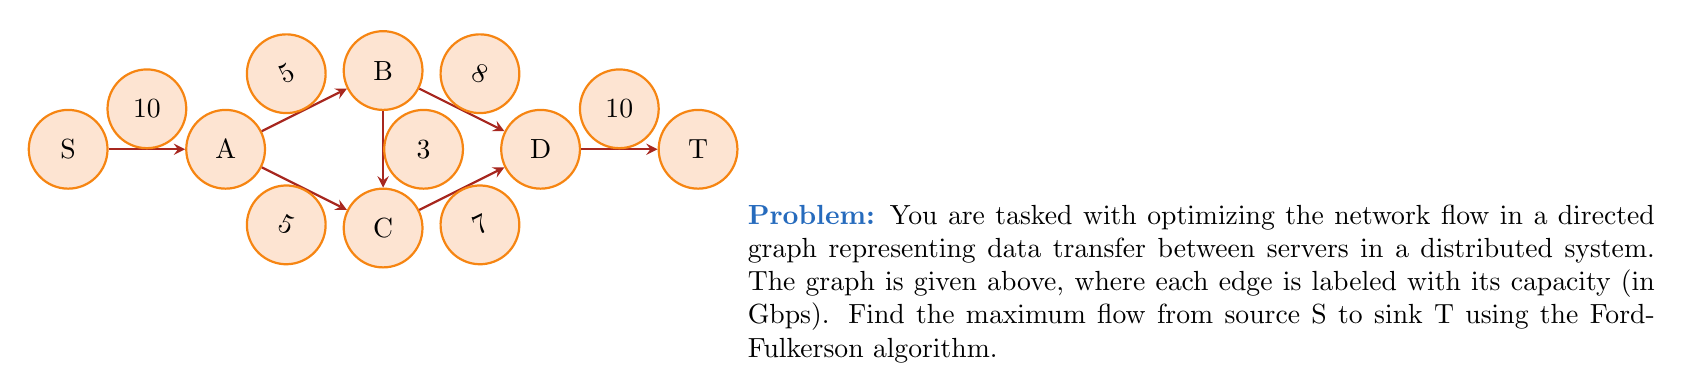Can you solve this math problem? To solve this problem using the Ford-Fulkerson algorithm, we'll follow these steps:

1) Initialize all flows to 0.
2) Find an augmenting path from S to T.
3) Determine the bottleneck capacity of this path.
4) Augment the flow along this path.
5) Repeat steps 2-4 until no augmenting path exists.

Let's go through the iterations:

Iteration 1:
Path: S -> A -> B -> D -> T
Bottleneck: min(10, 5, 8, 10) = 5
Flow: 5

Residual Graph:
S -> A: 5/10
A -> B: 5/5
B -> D: 5/8
D -> T: 5/10

Iteration 2:
Path: S -> A -> C -> D -> T
Bottleneck: min(5, 5, 7, 5) = 5
Flow: 5 + 5 = 10

Residual Graph:
S -> A: 0/10
A -> C: 5/5
C -> D: 5/7
D -> T: 0/10

Iteration 3:
Path: S -> A -> B -> C -> D -> T
Bottleneck: min(0, 0, 3, 2, 0) = 0

No more augmenting paths exist, so we've found the maximum flow.

The maximum flow is 10 Gbps, achieved by sending:
- 5 Gbps along S -> A -> B -> D -> T
- 5 Gbps along S -> A -> C -> D -> T
Answer: 10 Gbps 